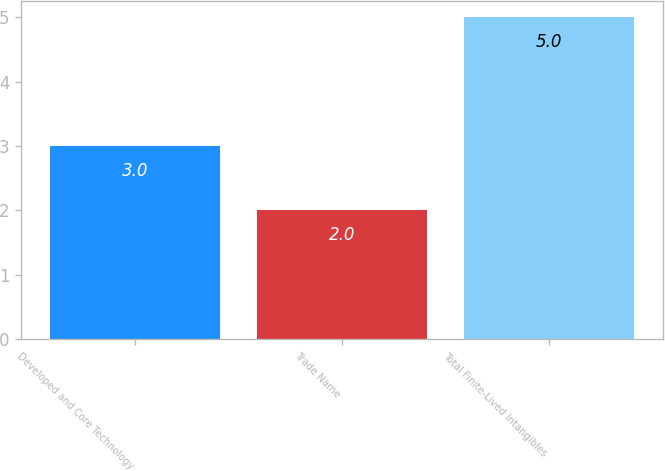<chart> <loc_0><loc_0><loc_500><loc_500><bar_chart><fcel>Developed and Core Technology<fcel>Trade Name<fcel>Total Finite-Lived Intangibles<nl><fcel>3<fcel>2<fcel>5<nl></chart> 